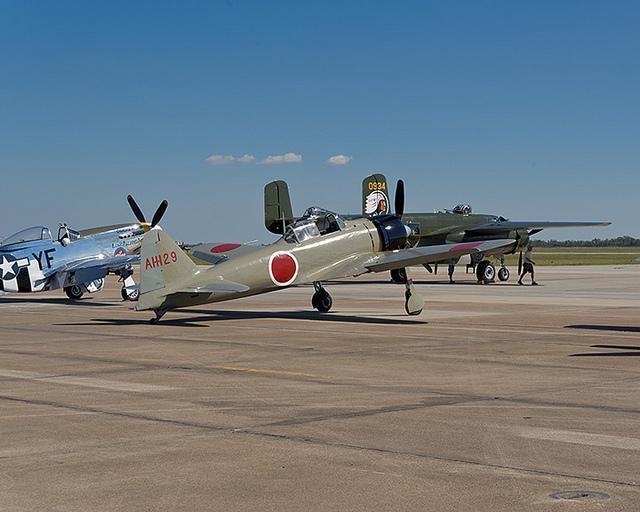How many planes are there?
Give a very brief answer. 3. How many airplanes are there in this image?
Give a very brief answer. 3. How many airplanes can you see?
Give a very brief answer. 2. How many chairs in this image are not placed at the table by the window?
Give a very brief answer. 0. 